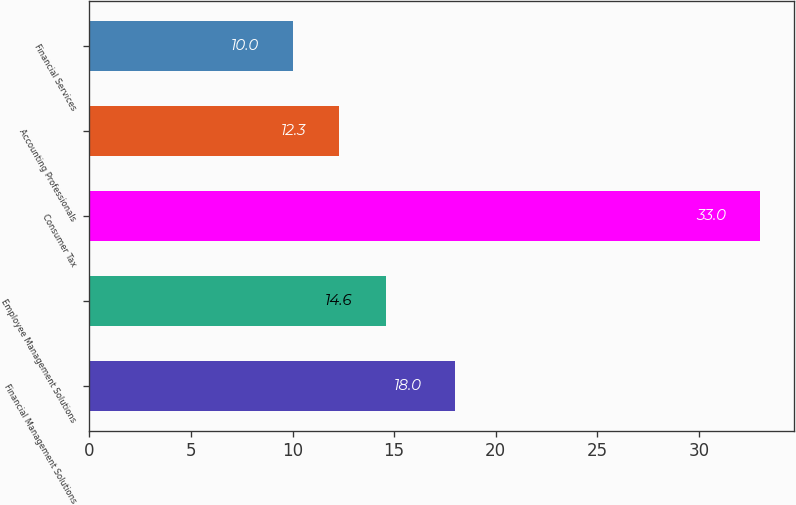Convert chart. <chart><loc_0><loc_0><loc_500><loc_500><bar_chart><fcel>Financial Management Solutions<fcel>Employee Management Solutions<fcel>Consumer Tax<fcel>Accounting Professionals<fcel>Financial Services<nl><fcel>18<fcel>14.6<fcel>33<fcel>12.3<fcel>10<nl></chart> 